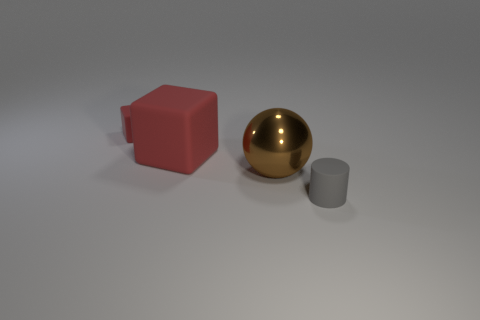Is there anything else that has the same material as the brown ball?
Offer a very short reply. No. There is a brown thing that is to the right of the large red matte object; how many tiny gray cylinders are behind it?
Give a very brief answer. 0. There is a brown ball; is its size the same as the rubber block in front of the tiny red rubber thing?
Keep it short and to the point. Yes. Is there a shiny cylinder that has the same size as the metal ball?
Offer a terse response. No. What number of things are either large cubes or red matte blocks?
Keep it short and to the point. 2. Is the size of the object in front of the large brown metal object the same as the rubber thing that is behind the big red matte cube?
Keep it short and to the point. Yes. Are there any other red things of the same shape as the tiny red object?
Offer a terse response. Yes. Are there fewer big brown metallic balls behind the large matte thing than large brown metallic balls?
Make the answer very short. Yes. Do the large red thing and the tiny red rubber thing have the same shape?
Your response must be concise. Yes. There is a metallic ball that is on the right side of the large rubber thing; what size is it?
Provide a succinct answer. Large. 